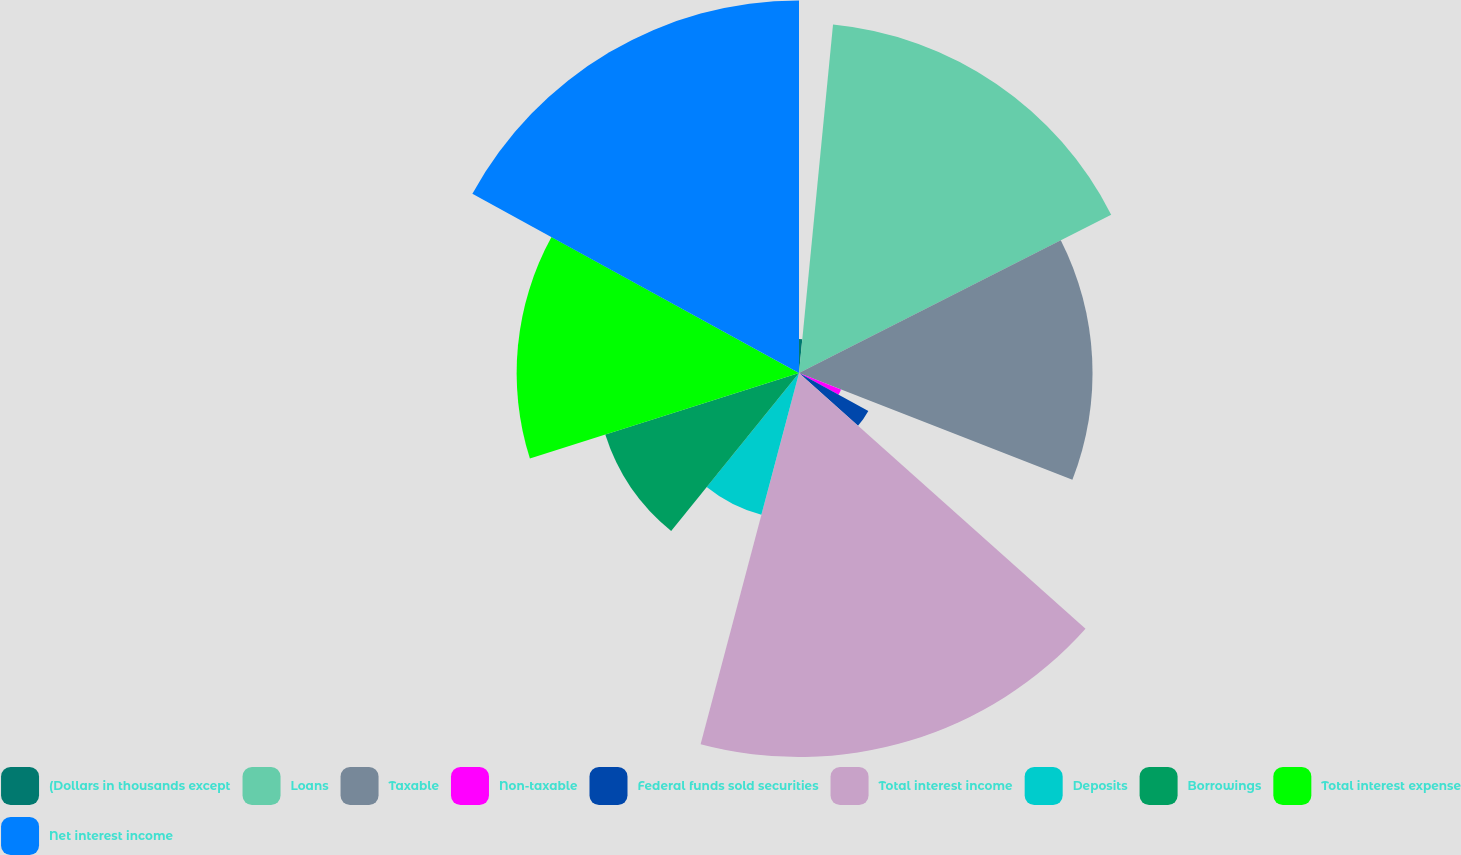Convert chart. <chart><loc_0><loc_0><loc_500><loc_500><pie_chart><fcel>(Dollars in thousands except<fcel>Loans<fcel>Taxable<fcel>Non-taxable<fcel>Federal funds sold securities<fcel>Total interest income<fcel>Deposits<fcel>Borrowings<fcel>Total interest expense<fcel>Net interest income<nl><fcel>1.55%<fcel>15.98%<fcel>13.4%<fcel>2.06%<fcel>3.61%<fcel>17.53%<fcel>6.7%<fcel>9.28%<fcel>12.89%<fcel>17.01%<nl></chart> 